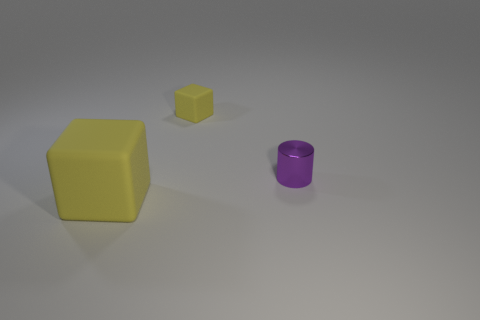There is a tiny block that is the same color as the big matte object; what material is it?
Your answer should be very brief. Rubber. There is another cube that is the same color as the tiny block; what size is it?
Ensure brevity in your answer.  Large. What number of other objects are there of the same shape as the tiny matte thing?
Your response must be concise. 1. There is a rubber thing that is behind the big yellow block; what shape is it?
Keep it short and to the point. Cube. Is the shape of the metal object the same as the yellow object behind the big rubber thing?
Offer a very short reply. No. What size is the object that is both right of the large block and to the left of the tiny purple metallic cylinder?
Your answer should be compact. Small. The object that is both left of the small shiny thing and right of the big rubber cube is what color?
Your answer should be compact. Yellow. Is there any other thing that has the same material as the tiny purple cylinder?
Your answer should be compact. No. Are there fewer purple metal things in front of the purple cylinder than matte objects that are to the right of the large block?
Offer a very short reply. Yes. Is there any other thing that has the same color as the big object?
Your answer should be very brief. Yes. 